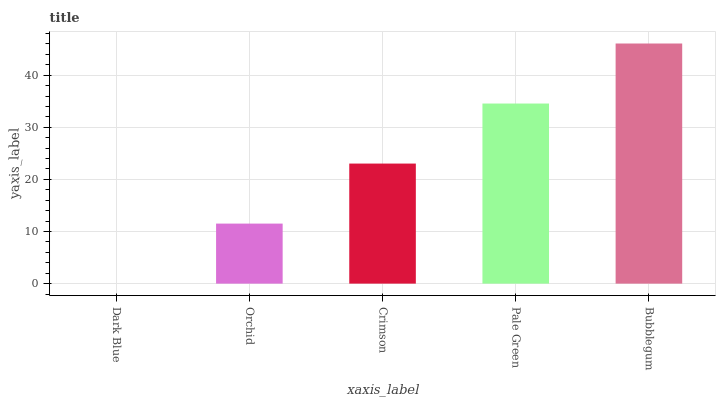Is Dark Blue the minimum?
Answer yes or no. Yes. Is Bubblegum the maximum?
Answer yes or no. Yes. Is Orchid the minimum?
Answer yes or no. No. Is Orchid the maximum?
Answer yes or no. No. Is Orchid greater than Dark Blue?
Answer yes or no. Yes. Is Dark Blue less than Orchid?
Answer yes or no. Yes. Is Dark Blue greater than Orchid?
Answer yes or no. No. Is Orchid less than Dark Blue?
Answer yes or no. No. Is Crimson the high median?
Answer yes or no. Yes. Is Crimson the low median?
Answer yes or no. Yes. Is Orchid the high median?
Answer yes or no. No. Is Pale Green the low median?
Answer yes or no. No. 